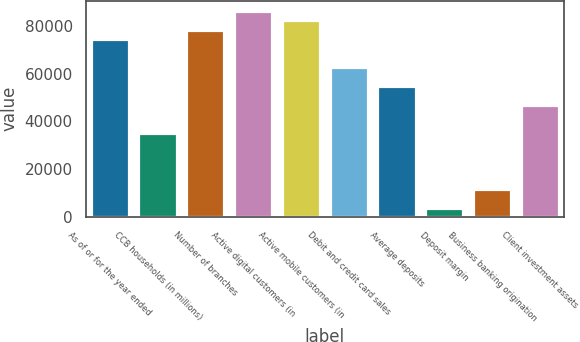<chart> <loc_0><loc_0><loc_500><loc_500><bar_chart><fcel>As of or for the year ended<fcel>CCB households (in millions)<fcel>Number of branches<fcel>Active digital customers (in<fcel>Active mobile customers (in<fcel>Debit and credit card sales<fcel>Average deposits<fcel>Deposit margin<fcel>Business banking origination<fcel>Client investment assets<nl><fcel>74558.9<fcel>35317.9<fcel>78483<fcel>86331.2<fcel>82407.1<fcel>62786.6<fcel>54938.4<fcel>3925.08<fcel>11773.3<fcel>47090.2<nl></chart> 